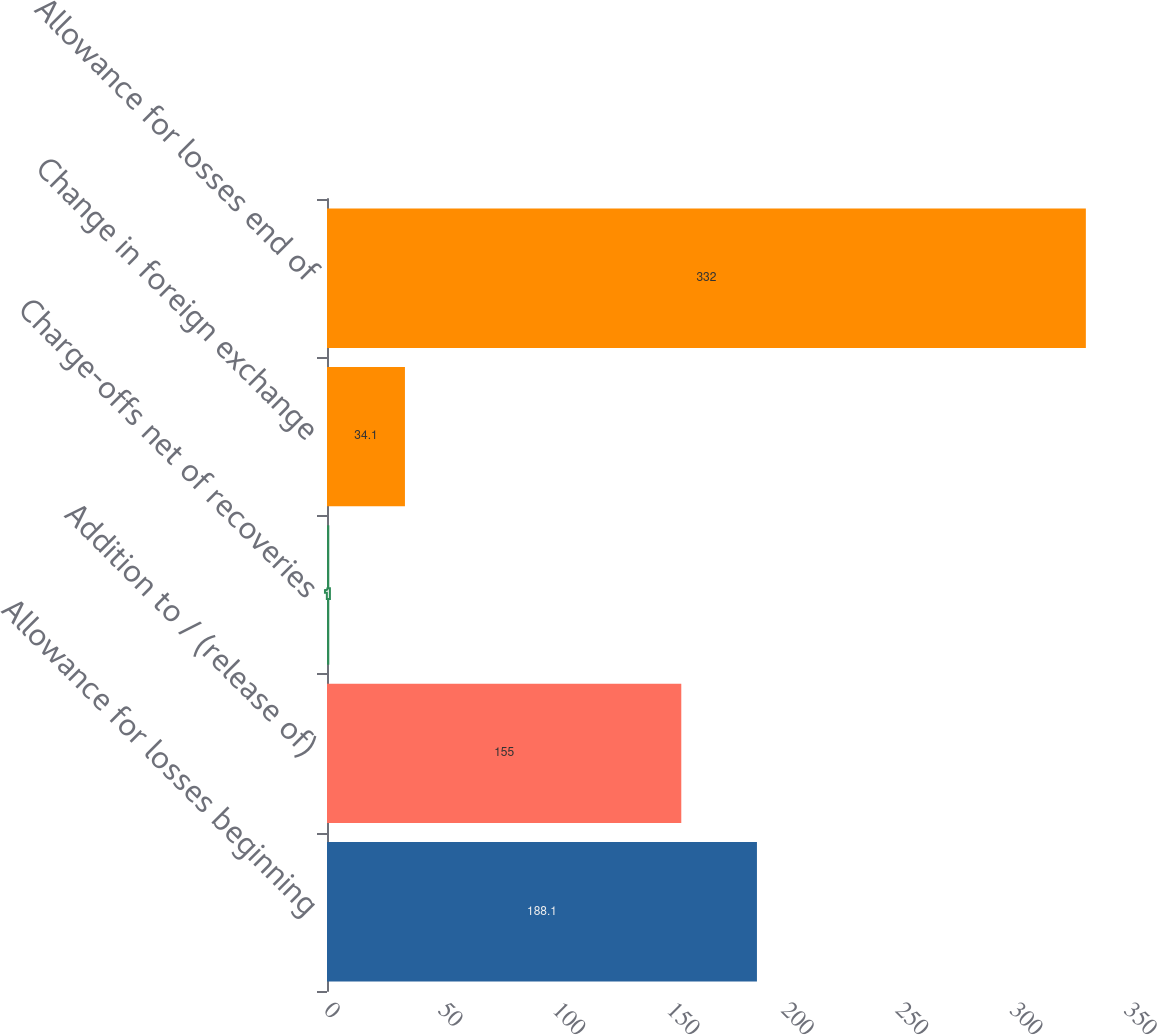Convert chart to OTSL. <chart><loc_0><loc_0><loc_500><loc_500><bar_chart><fcel>Allowance for losses beginning<fcel>Addition to / (release of)<fcel>Charge-offs net of recoveries<fcel>Change in foreign exchange<fcel>Allowance for losses end of<nl><fcel>188.1<fcel>155<fcel>1<fcel>34.1<fcel>332<nl></chart> 